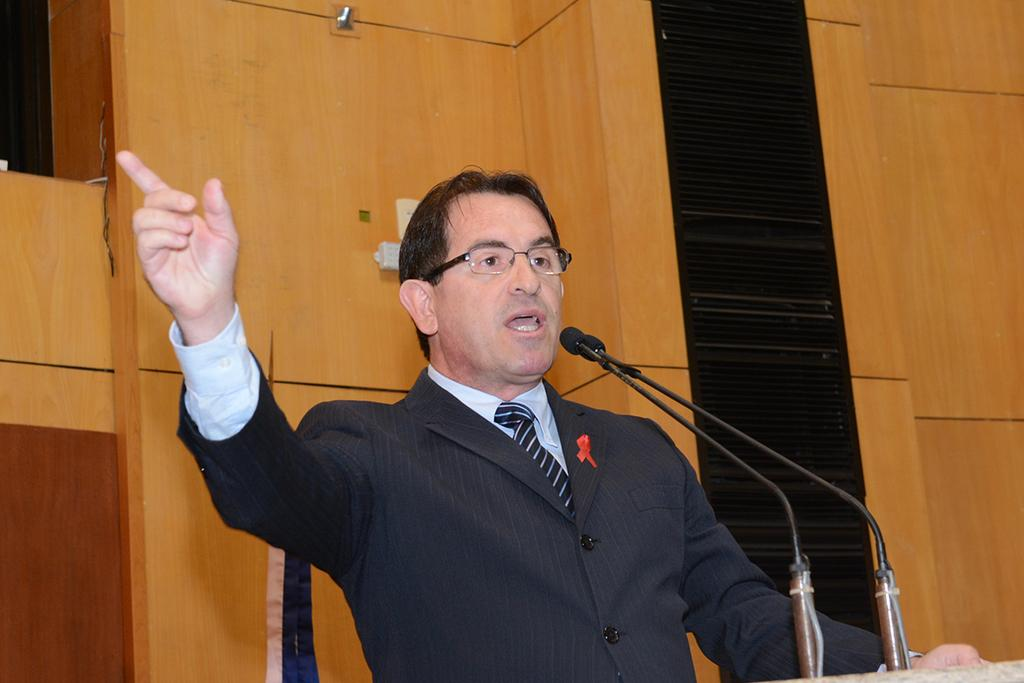Who is present in the image? There is a person in the image. What can be observed about the person's appearance? The person is wearing glasses (specs). What is the person doing in the image? The person is speaking. What objects are in front of the person? There are microphones (mics) in front of the person. What can be seen in the background of the image? There is a wall in the background of the image. What type of ocean can be seen in the background of the image? There is no ocean present in the image; it features a wall in the background. How does the person express disgust in the image? The image does not show the person expressing disgust; they are speaking with microphones in front of them. 